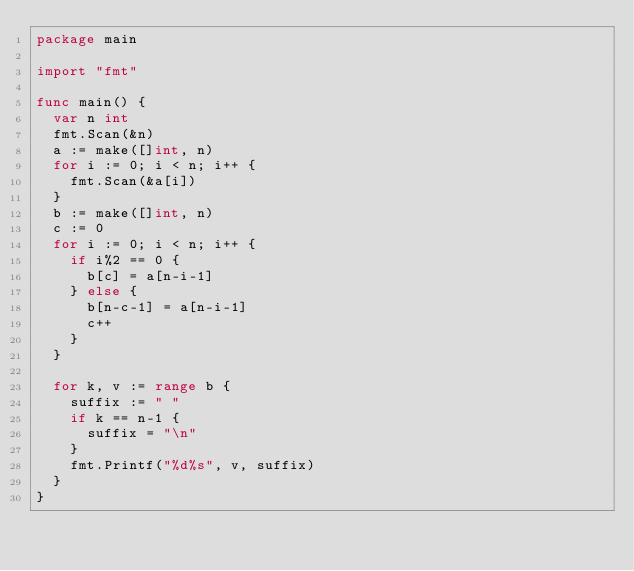Convert code to text. <code><loc_0><loc_0><loc_500><loc_500><_Go_>package main

import "fmt"

func main() {
	var n int
	fmt.Scan(&n)
	a := make([]int, n)
	for i := 0; i < n; i++ {
		fmt.Scan(&a[i])
	}
	b := make([]int, n)
	c := 0
	for i := 0; i < n; i++ {
		if i%2 == 0 {
			b[c] = a[n-i-1]
		} else {
			b[n-c-1] = a[n-i-1]
			c++
		}
	}

	for k, v := range b {
		suffix := " "
		if k == n-1 {
			suffix = "\n"
		}
		fmt.Printf("%d%s", v, suffix)
	}
}
</code> 